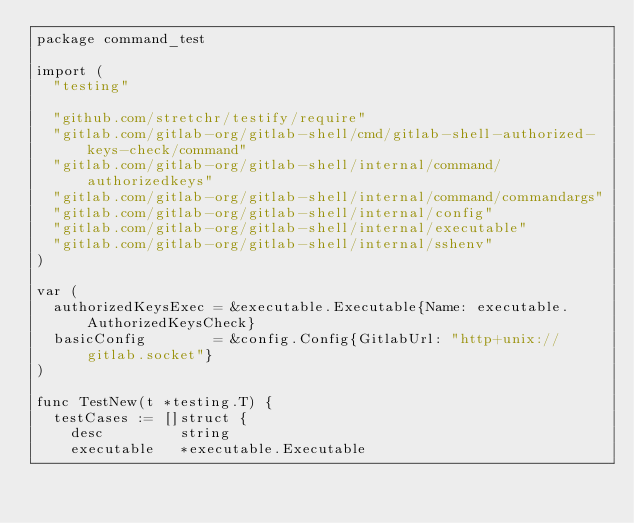<code> <loc_0><loc_0><loc_500><loc_500><_Go_>package command_test

import (
	"testing"

	"github.com/stretchr/testify/require"
	"gitlab.com/gitlab-org/gitlab-shell/cmd/gitlab-shell-authorized-keys-check/command"
	"gitlab.com/gitlab-org/gitlab-shell/internal/command/authorizedkeys"
	"gitlab.com/gitlab-org/gitlab-shell/internal/command/commandargs"
	"gitlab.com/gitlab-org/gitlab-shell/internal/config"
	"gitlab.com/gitlab-org/gitlab-shell/internal/executable"
	"gitlab.com/gitlab-org/gitlab-shell/internal/sshenv"
)

var (
	authorizedKeysExec = &executable.Executable{Name: executable.AuthorizedKeysCheck}
	basicConfig        = &config.Config{GitlabUrl: "http+unix://gitlab.socket"}
)

func TestNew(t *testing.T) {
	testCases := []struct {
		desc         string
		executable   *executable.Executable</code> 